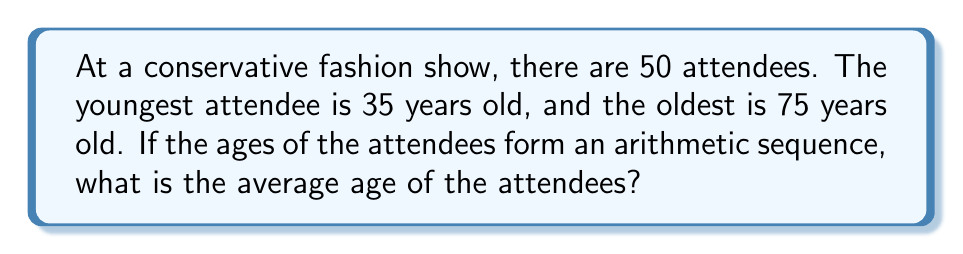Solve this math problem. Let's approach this step-by-step:

1) In an arithmetic sequence, the difference between each term is constant. Let's call this common difference $d$.

2) Given that there are 50 terms (attendees), and the first term $a_1 = 35$ (youngest) and the last term $a_{50} = 75$ (oldest), we can use the arithmetic sequence formula:

   $a_n = a_1 + (n-1)d$

   Where $n = 50$, $a_1 = 35$, and $a_{50} = 75$

3) Substituting these values:

   $75 = 35 + (50-1)d$
   $75 = 35 + 49d$

4) Solving for $d$:

   $40 = 49d$
   $d = \frac{40}{49} \approx 0.8163$

5) The average of an arithmetic sequence is the mean of the first and last terms:

   $\text{Average} = \frac{a_1 + a_n}{2} = \frac{35 + 75}{2} = \frac{110}{2} = 55$

Therefore, the average age of the attendees is 55 years old.
Answer: 55 years 